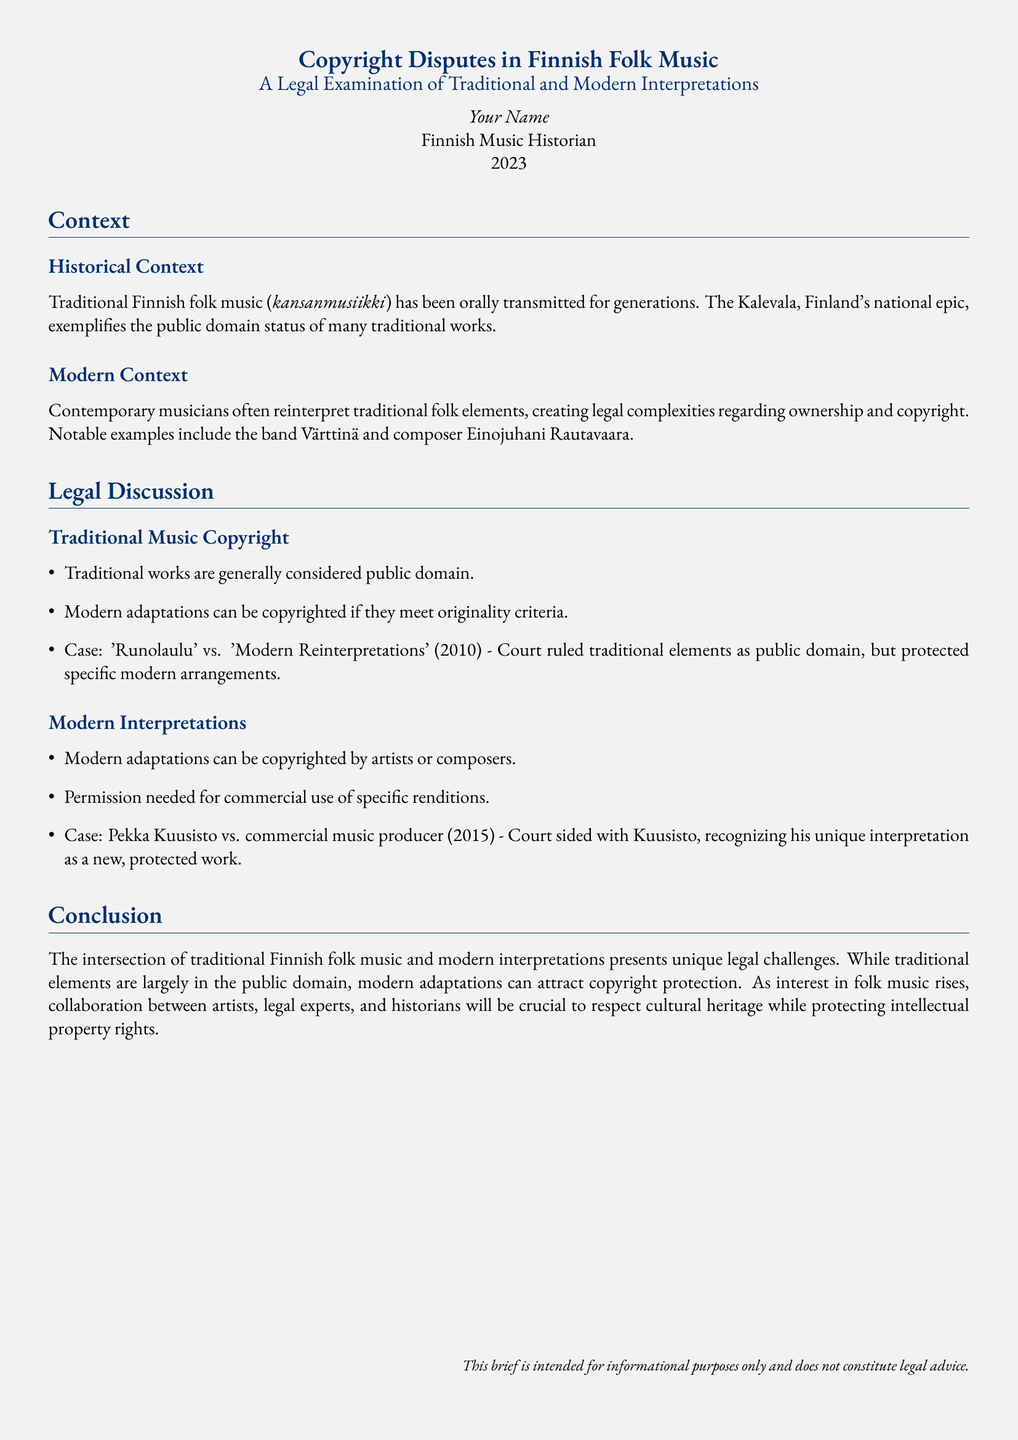What is the title of the document? The title is clearly stated in the header section of the document.
Answer: Copyright Disputes in Finnish Folk Music Who is the author of the document? The author is mentioned at the end of the introduction section.
Answer: Your Name What year was the brief written? The year is specified in the introduction section.
Answer: 2023 What was the outcome of the case 'Runolaulu' vs. 'Modern Reinterpretations'? The outcome is summarized in the Legal Discussion section, regarding the treatment of traditional and modern elements.
Answer: Traditional elements as public domain Which band is noted for its reinterpretation of traditional folk elements? The band is mentioned in the Modern Context section as an example.
Answer: Värttinä What legal requirement is necessary for commercial use of modern adaptations? This requirement is discussed under the Modern Interpretations section.
Answer: Permission needed In what year did the case involving Pekka Kuusisto occur? The year is specified in the discussion of the Modern Interpretations section.
Answer: 2015 What type of music has been orally transmitted for generations according to the document? The document discusses a specific music genre in historical context.
Answer: Traditional Finnish folk music What do traditional works generally fall under legally? This categorization is stated in the Legal Discussion section regarding traditional music.
Answer: Public domain 